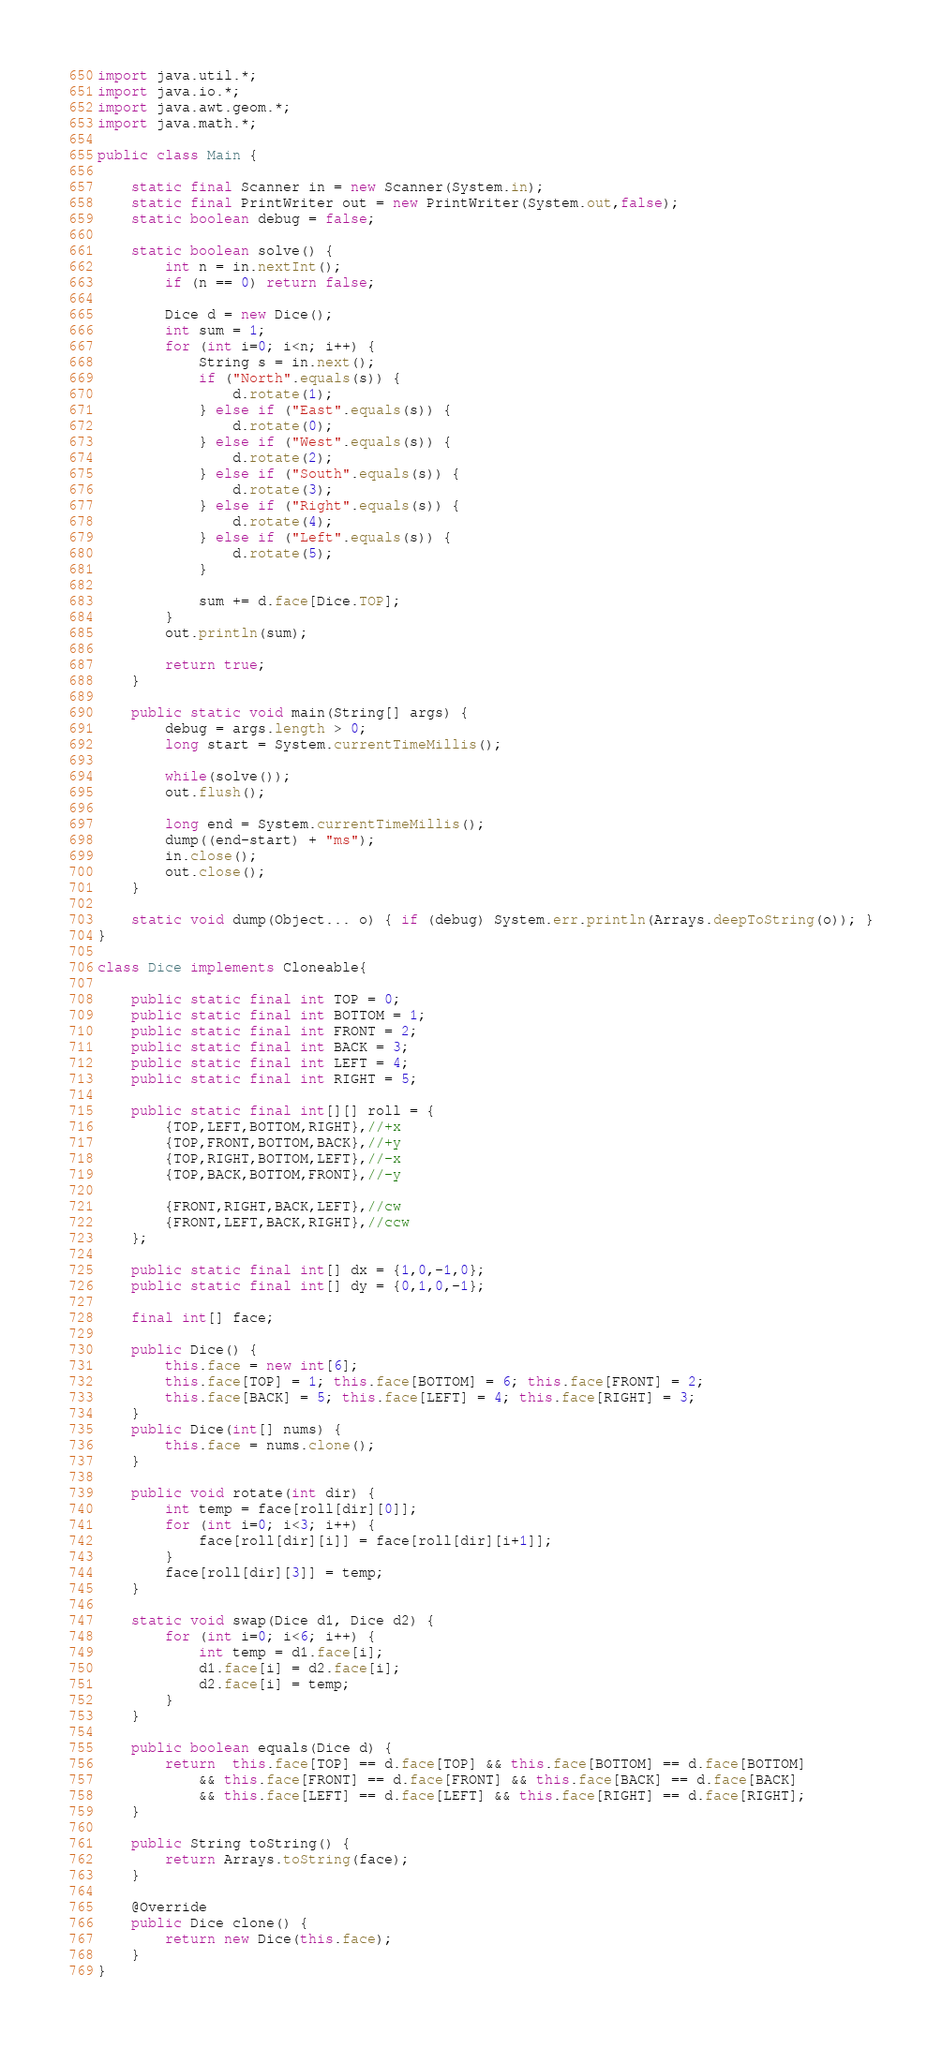Convert code to text. <code><loc_0><loc_0><loc_500><loc_500><_Java_>import java.util.*;
import java.io.*;
import java.awt.geom.*;
import java.math.*;

public class Main {

	static final Scanner in = new Scanner(System.in);
	static final PrintWriter out = new PrintWriter(System.out,false);
	static boolean debug = false;

	static boolean solve() {
		int n = in.nextInt();
		if (n == 0) return false;

		Dice d = new Dice();
		int sum = 1;
		for (int i=0; i<n; i++) {
			String s = in.next();
			if ("North".equals(s)) {
				d.rotate(1);
			} else if ("East".equals(s)) {
				d.rotate(0);
			} else if ("West".equals(s)) {
				d.rotate(2);
			} else if ("South".equals(s)) {
				d.rotate(3);
			} else if ("Right".equals(s)) {
				d.rotate(4);
			} else if ("Left".equals(s)) {
				d.rotate(5);
			}

			sum += d.face[Dice.TOP];
		}
		out.println(sum);

		return true;
	}

	public static void main(String[] args) {
		debug = args.length > 0;
		long start = System.currentTimeMillis();

		while(solve());
		out.flush();

		long end = System.currentTimeMillis();
		dump((end-start) + "ms");
		in.close();
		out.close();
	}

	static void dump(Object... o) { if (debug) System.err.println(Arrays.deepToString(o)); }
}

class Dice implements Cloneable{

	public static final int TOP = 0;
	public static final int BOTTOM = 1;
	public static final int FRONT = 2;
	public static final int BACK = 3;
	public static final int LEFT = 4;
	public static final int RIGHT = 5;

	public static final int[][] roll = {
		{TOP,LEFT,BOTTOM,RIGHT},//+x
		{TOP,FRONT,BOTTOM,BACK},//+y
		{TOP,RIGHT,BOTTOM,LEFT},//-x
		{TOP,BACK,BOTTOM,FRONT},//-y

		{FRONT,RIGHT,BACK,LEFT},//cw
		{FRONT,LEFT,BACK,RIGHT},//ccw
	};

	public static final int[] dx = {1,0,-1,0};
	public static final int[] dy = {0,1,0,-1};

	final int[] face;

	public Dice() {
		this.face = new int[6];
		this.face[TOP] = 1; this.face[BOTTOM] = 6; this.face[FRONT] = 2;
		this.face[BACK] = 5; this.face[LEFT] = 4; this.face[RIGHT] = 3;
	}
	public Dice(int[] nums) {
		this.face = nums.clone();
	}

	public void rotate(int dir) {
		int temp = face[roll[dir][0]];
		for (int i=0; i<3; i++) {
			face[roll[dir][i]] = face[roll[dir][i+1]];
		}
		face[roll[dir][3]] = temp;
	}

	static void swap(Dice d1, Dice d2) {
		for (int i=0; i<6; i++) {
			int temp = d1.face[i];
			d1.face[i] = d2.face[i];
			d2.face[i] = temp;
		}
	}

	public boolean equals(Dice d) {
		return  this.face[TOP] == d.face[TOP] && this.face[BOTTOM] == d.face[BOTTOM]
			&& this.face[FRONT] == d.face[FRONT] && this.face[BACK] == d.face[BACK]
			&& this.face[LEFT] == d.face[LEFT] && this.face[RIGHT] == d.face[RIGHT];
	}

	public String toString() {
		return Arrays.toString(face);
	}

	@Override
	public Dice clone() {
		return new Dice(this.face);
	}
}</code> 